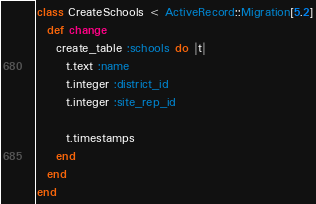<code> <loc_0><loc_0><loc_500><loc_500><_Ruby_>class CreateSchools < ActiveRecord::Migration[5.2]
  def change
    create_table :schools do |t|
      t.text :name
      t.integer :district_id
      t.integer :site_rep_id

      t.timestamps
    end
  end
end
</code> 